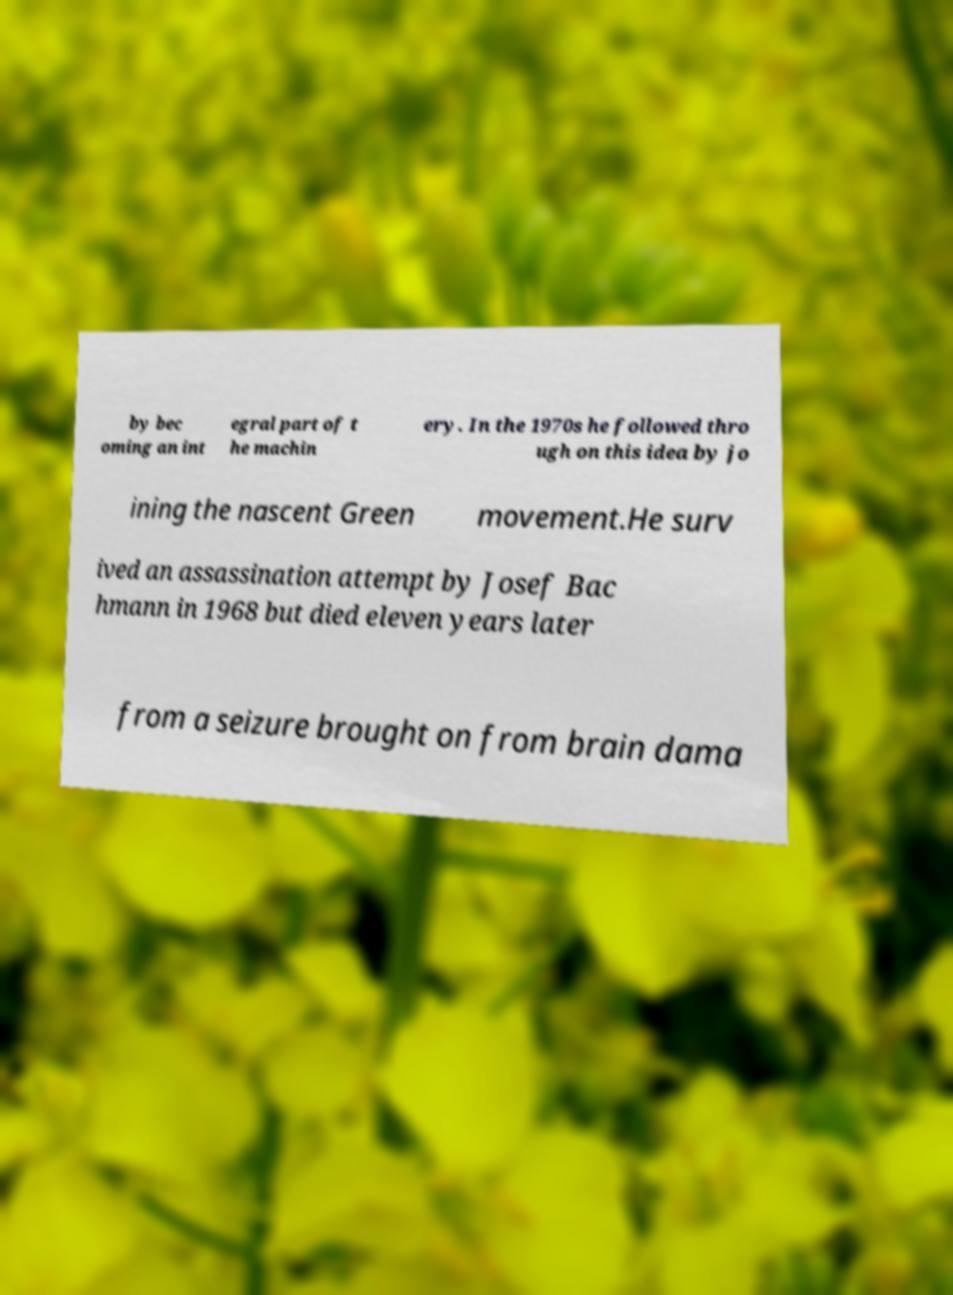Could you assist in decoding the text presented in this image and type it out clearly? by bec oming an int egral part of t he machin ery. In the 1970s he followed thro ugh on this idea by jo ining the nascent Green movement.He surv ived an assassination attempt by Josef Bac hmann in 1968 but died eleven years later from a seizure brought on from brain dama 